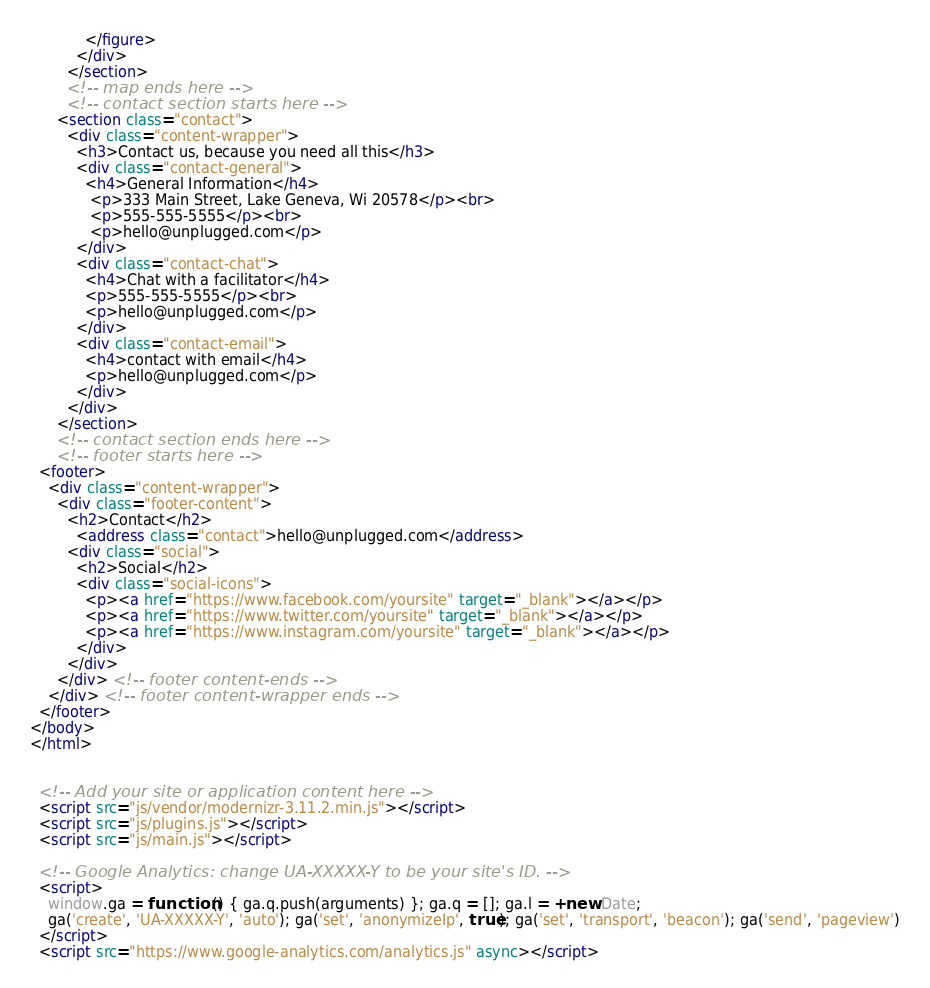Convert code to text. <code><loc_0><loc_0><loc_500><loc_500><_HTML_>            </figure>
          </div>
        </section>
        <!-- map ends here -->
        <!-- contact section starts here -->
      <section class="contact">
        <div class="content-wrapper">
          <h3>Contact us, because you need all this</h3>
          <div class="contact-general">
            <h4>General Information</h4>
             <p>333 Main Street, Lake Geneva, Wi 20578</p><br>
             <p>555-555-5555</p><br>
             <p>hello@unplugged.com</p>
          </div>
          <div class="contact-chat">
            <h4>Chat with a facilitator</h4>
            <p>555-555-5555</p><br>
            <p>hello@unplugged.com</p>
          </div>
          <div class="contact-email">
            <h4>contact with email</h4>
            <p>hello@unplugged.com</p>
          </div>
        </div>
      </section>
      <!-- contact section ends here -->
      <!-- footer starts here -->
  <footer>
    <div class="content-wrapper">
      <div class="footer-content">
        <h2>Contact</h2>
          <address class="contact">hello@unplugged.com</address>
        <div class="social">
          <h2>Social</h2>
          <div class="social-icons">
            <p><a href="https://www.facebook.com/yoursite" target="_blank"></a></p>
            <p><a href="https://www.twitter.com/yoursite" target="_blank"></a></p>
            <p><a href="https://www.instagram.com/yoursite" target="_blank"></a></p>
          </div>
        </div>
      </div> <!-- footer content-ends -->
    </div> <!-- footer content-wrapper ends -->
  </footer>
</body>
</html>


  <!-- Add your site or application content here -->
  <script src="js/vendor/modernizr-3.11.2.min.js"></script>
  <script src="js/plugins.js"></script>
  <script src="js/main.js"></script>

  <!-- Google Analytics: change UA-XXXXX-Y to be your site's ID. -->
  <script>
    window.ga = function () { ga.q.push(arguments) }; ga.q = []; ga.l = +new Date;
    ga('create', 'UA-XXXXX-Y', 'auto'); ga('set', 'anonymizeIp', true); ga('set', 'transport', 'beacon'); ga('send', 'pageview')
  </script>
  <script src="https://www.google-analytics.com/analytics.js" async></script>
</code> 